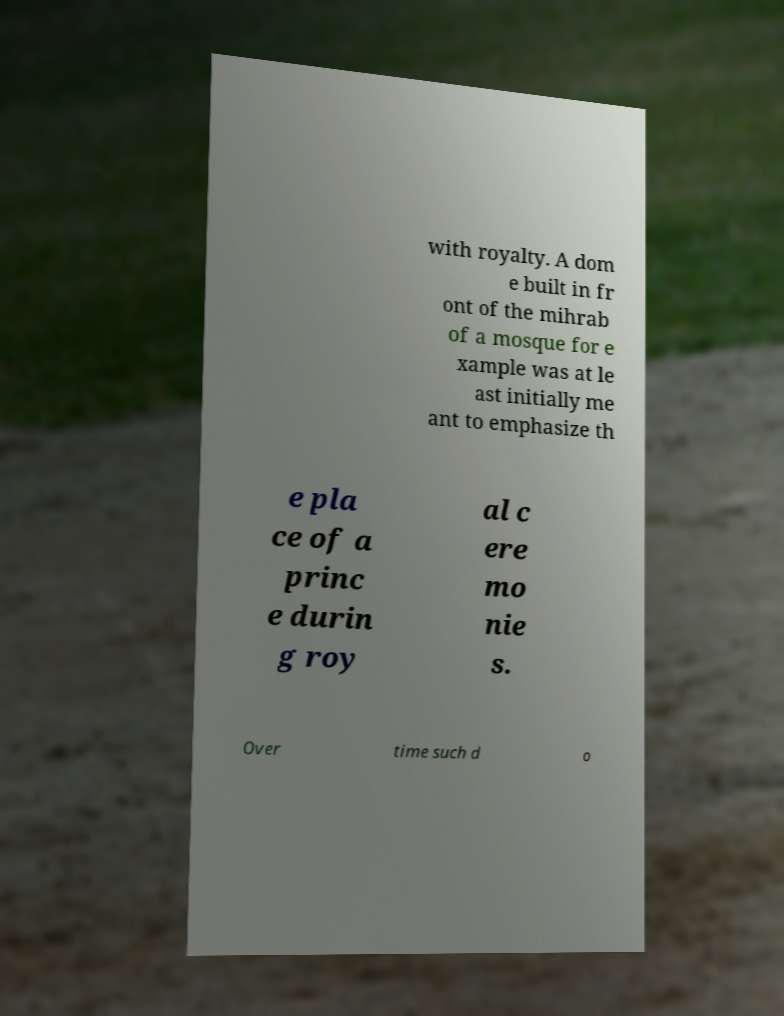I need the written content from this picture converted into text. Can you do that? with royalty. A dom e built in fr ont of the mihrab of a mosque for e xample was at le ast initially me ant to emphasize th e pla ce of a princ e durin g roy al c ere mo nie s. Over time such d o 